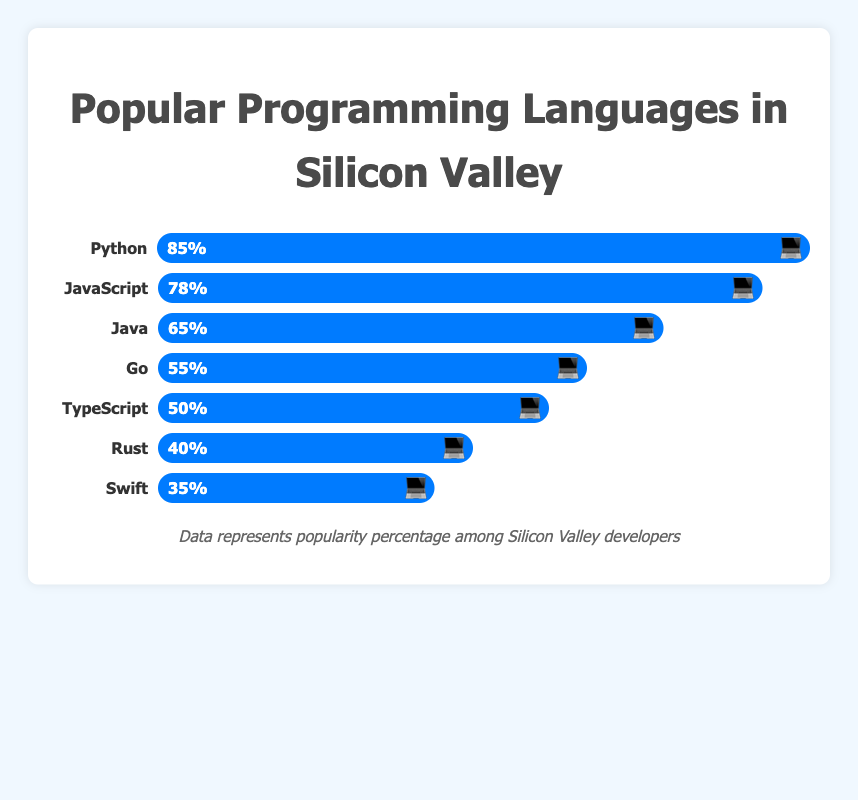What are the top three most popular programming languages among Silicon Valley developers? 💻 The top three popular programming languages among Silicon Valley developers, based on the percentage by which they are represented, are Python at 85%, JavaScript at 78%, and Java at 65%. This can be seen from the bar lengths with corresponding values and emojis in the chart.
Answer: Python, JavaScript, Java What is the difference in popularity between Go and Rust? 💻 The popularity of Go is 55%, while the popularity of Rust is 40%. Subtract the two values to find the difference: 55% - 40% = 15%.
Answer: 15% Which programming language is precisely one rank below JavaScript in terms of popularity? 💻 Observing the chart, JavaScript is second highest in popularity at 78%. The language immediately below it, in descending order, is Java with 65%.
Answer: Java Which programming language holds the median value in terms of popularity? 💻 There are seven languages listed. The median value falls on the fourth language in a sorted list. Sorting by percentage, the order is Swift (35%), Rust (40%), TypeScript (50%), Go (55%), Java (65%), JavaScript (78%), Python (85%). Therefore, Go, the fourth language, holds the median value at 55%.
Answer: Go How much more popular is TypeScript compared to Swift? 💻 The popularity of TypeScript is 50%, and for Swift, it is 35%. The difference is found by subtracting the smaller percentage from the larger one: 50% - 35% = 15%.
Answer: 15% What percentage of developers prefer languages other than Python, JavaScript, and Java combined? 💻 First, sum up the percentages of Python (85%), JavaScript (78%), and Java (65%) which is 85% + 78% + 65% = 228%. The total sum of all percentages is 100% * 7 languages = 700%. Subtract the combined popularity of these three languages from the total: 700% - 228% = 472%.
Answer: 472% Which language has the least popularity on the chart? 💻 By examining the length of the bars, Swift is the language with the shortest bar, indicating the lowest popularity at 35%.
Answer: Swift If a company wants to focus on the top 50% most popular programming languages, which languages should they concentrate on? 💻 The top 50% popular languages considering the sorted list are Python (85%), JavaScript (78%), Java (65%). Summing these percentages until half is exceeded: 85% + 78% + 65% = 228%. Since 228% is more than 50% of the total 700%, they should focus on Python, JavaScript, and Java.
Answer: Python, JavaScript, Java 